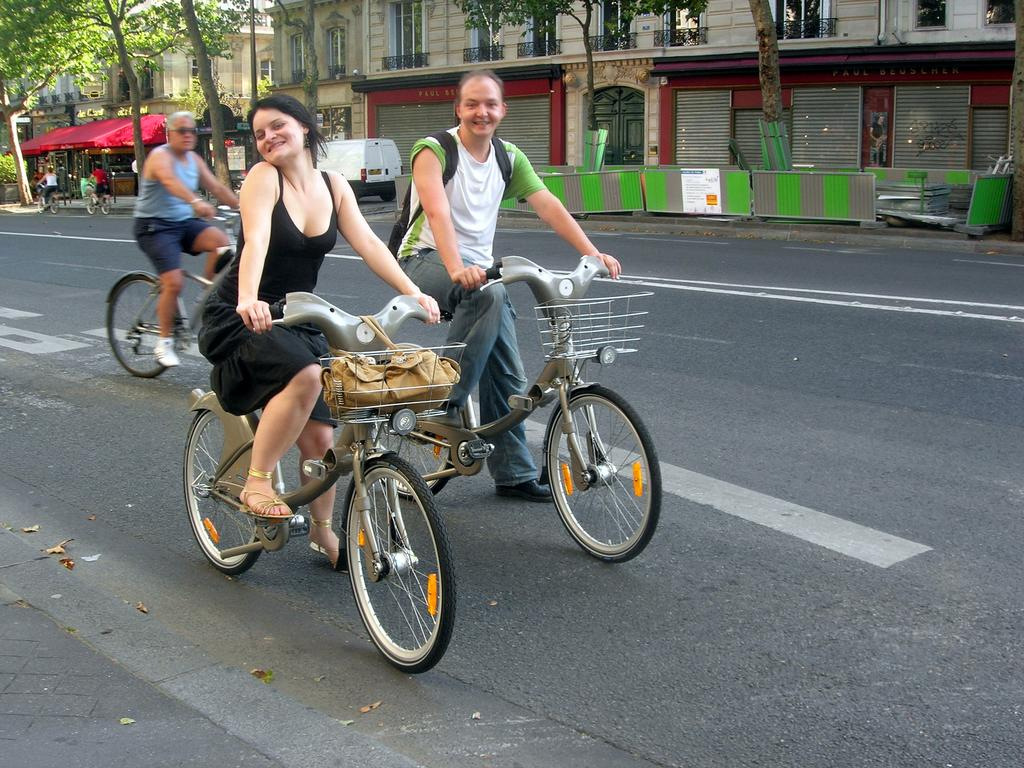How many people are in the image? There are five persons in the image. What are the persons doing in the image? The persons are riding bicycles. Where are the bicycles located? The bicycles are on the road. What can be seen in the background of the image? There is a car, a house, and trees in the background of the image. Can you tell me how many hands are visible on the persons riding bicycles in the image? It is not possible to determine the exact number of hands visible on the persons riding bicycles in the image, as hands may be partially or fully obscured by the bicycles or other objects. 